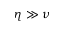<formula> <loc_0><loc_0><loc_500><loc_500>\eta \gg \nu</formula> 